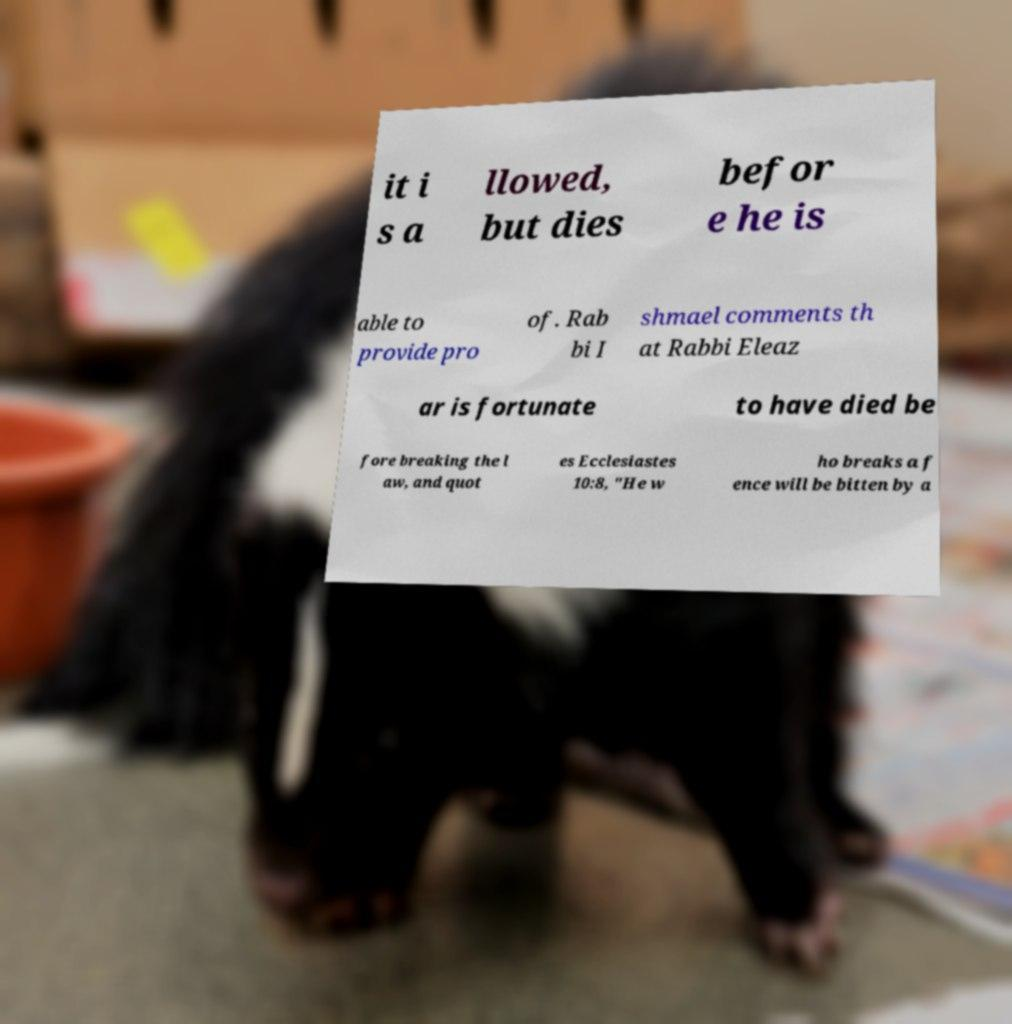Can you accurately transcribe the text from the provided image for me? it i s a llowed, but dies befor e he is able to provide pro of. Rab bi I shmael comments th at Rabbi Eleaz ar is fortunate to have died be fore breaking the l aw, and quot es Ecclesiastes 10:8, "He w ho breaks a f ence will be bitten by a 